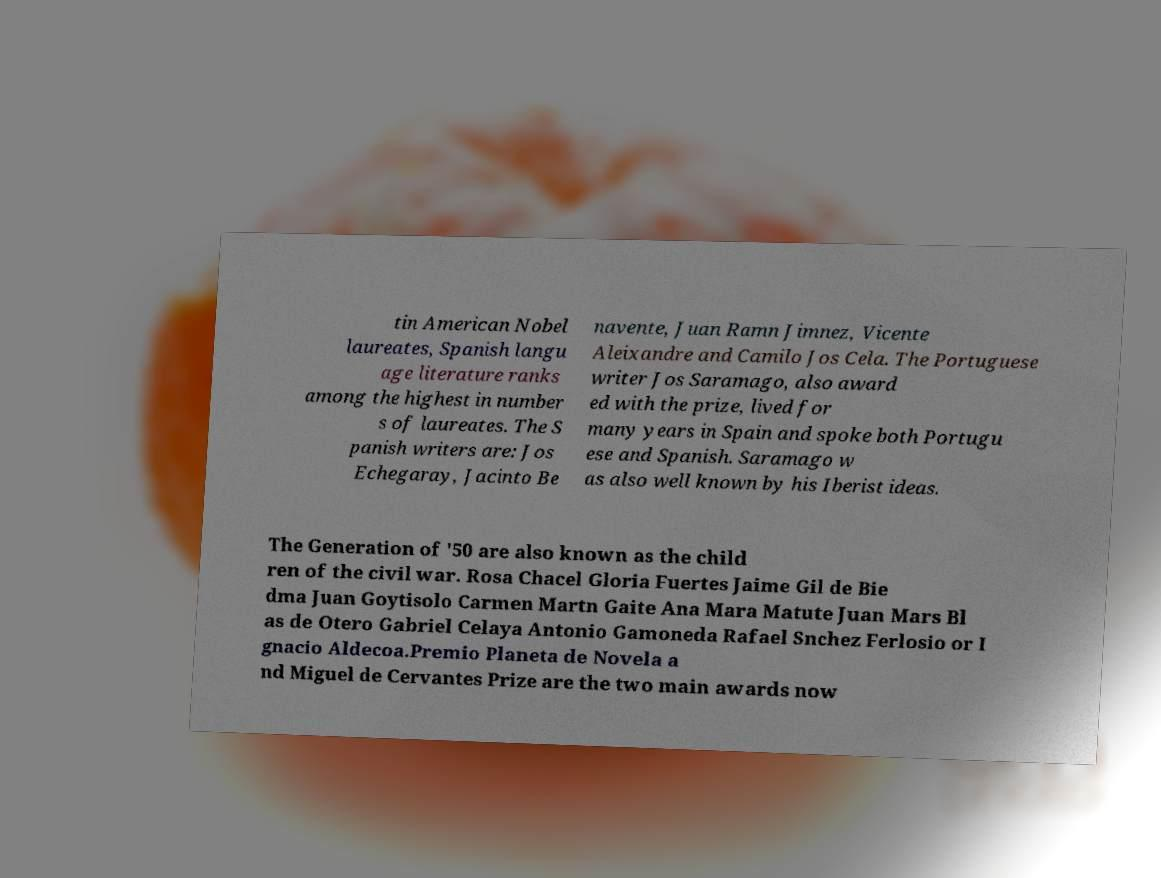Can you accurately transcribe the text from the provided image for me? tin American Nobel laureates, Spanish langu age literature ranks among the highest in number s of laureates. The S panish writers are: Jos Echegaray, Jacinto Be navente, Juan Ramn Jimnez, Vicente Aleixandre and Camilo Jos Cela. The Portuguese writer Jos Saramago, also award ed with the prize, lived for many years in Spain and spoke both Portugu ese and Spanish. Saramago w as also well known by his Iberist ideas. The Generation of '50 are also known as the child ren of the civil war. Rosa Chacel Gloria Fuertes Jaime Gil de Bie dma Juan Goytisolo Carmen Martn Gaite Ana Mara Matute Juan Mars Bl as de Otero Gabriel Celaya Antonio Gamoneda Rafael Snchez Ferlosio or I gnacio Aldecoa.Premio Planeta de Novela a nd Miguel de Cervantes Prize are the two main awards now 